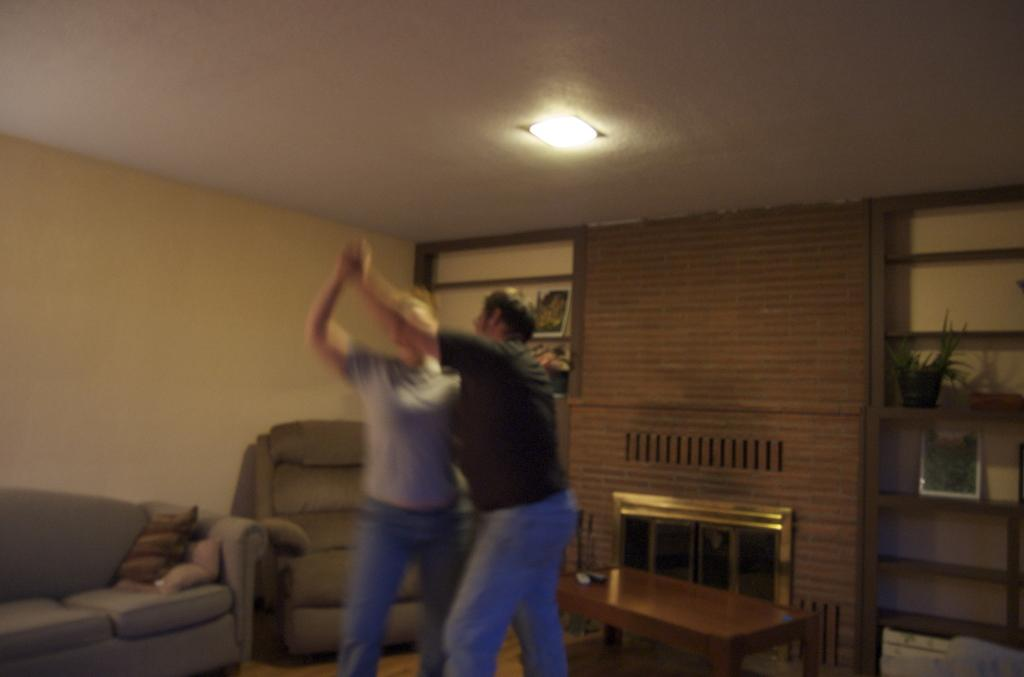What type of space is depicted in the image? The image shows an inner view of a room. What furniture is present in the room? There is a couch and a chair in the room. What activity are the two people in the room engaged in? Two people are performing a dance in the room. What type of joke can be seen on the moon in the image? There is no moon or joke present in the image; it depicts an inner view of a room with a couch, a chair, and two people dancing. 